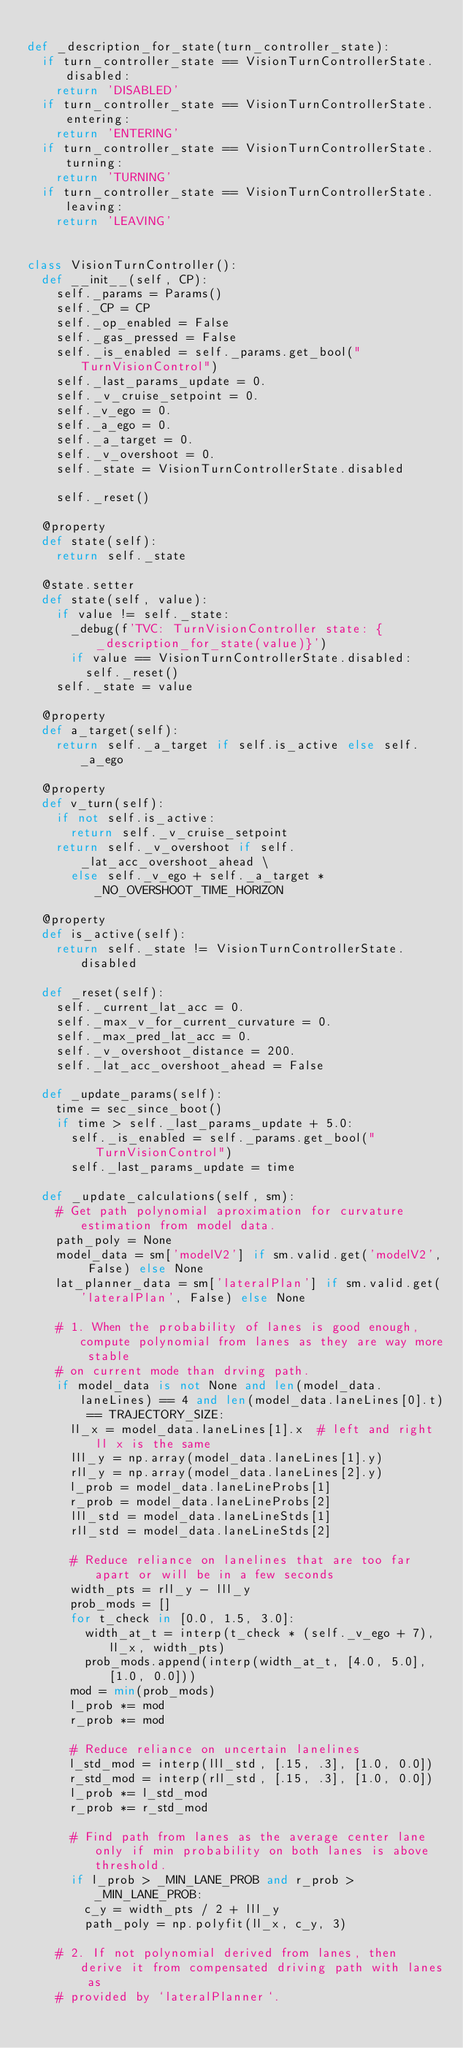<code> <loc_0><loc_0><loc_500><loc_500><_Python_>
def _description_for_state(turn_controller_state):
  if turn_controller_state == VisionTurnControllerState.disabled:
    return 'DISABLED'
  if turn_controller_state == VisionTurnControllerState.entering:
    return 'ENTERING'
  if turn_controller_state == VisionTurnControllerState.turning:
    return 'TURNING'
  if turn_controller_state == VisionTurnControllerState.leaving:
    return 'LEAVING'


class VisionTurnController():
  def __init__(self, CP):
    self._params = Params()
    self._CP = CP
    self._op_enabled = False
    self._gas_pressed = False
    self._is_enabled = self._params.get_bool("TurnVisionControl")
    self._last_params_update = 0.
    self._v_cruise_setpoint = 0.
    self._v_ego = 0.
    self._a_ego = 0.
    self._a_target = 0.
    self._v_overshoot = 0.
    self._state = VisionTurnControllerState.disabled

    self._reset()

  @property
  def state(self):
    return self._state

  @state.setter
  def state(self, value):
    if value != self._state:
      _debug(f'TVC: TurnVisionController state: {_description_for_state(value)}')
      if value == VisionTurnControllerState.disabled:
        self._reset()
    self._state = value

  @property
  def a_target(self):
    return self._a_target if self.is_active else self._a_ego

  @property
  def v_turn(self):
    if not self.is_active:
      return self._v_cruise_setpoint
    return self._v_overshoot if self._lat_acc_overshoot_ahead \
      else self._v_ego + self._a_target * _NO_OVERSHOOT_TIME_HORIZON

  @property
  def is_active(self):
    return self._state != VisionTurnControllerState.disabled

  def _reset(self):
    self._current_lat_acc = 0.
    self._max_v_for_current_curvature = 0.
    self._max_pred_lat_acc = 0.
    self._v_overshoot_distance = 200.
    self._lat_acc_overshoot_ahead = False

  def _update_params(self):
    time = sec_since_boot()
    if time > self._last_params_update + 5.0:
      self._is_enabled = self._params.get_bool("TurnVisionControl")
      self._last_params_update = time

  def _update_calculations(self, sm):
    # Get path polynomial aproximation for curvature estimation from model data.
    path_poly = None
    model_data = sm['modelV2'] if sm.valid.get('modelV2', False) else None
    lat_planner_data = sm['lateralPlan'] if sm.valid.get('lateralPlan', False) else None

    # 1. When the probability of lanes is good enough, compute polynomial from lanes as they are way more stable
    # on current mode than drving path.
    if model_data is not None and len(model_data.laneLines) == 4 and len(model_data.laneLines[0].t) == TRAJECTORY_SIZE:
      ll_x = model_data.laneLines[1].x  # left and right ll x is the same
      lll_y = np.array(model_data.laneLines[1].y)
      rll_y = np.array(model_data.laneLines[2].y)
      l_prob = model_data.laneLineProbs[1]
      r_prob = model_data.laneLineProbs[2]
      lll_std = model_data.laneLineStds[1]
      rll_std = model_data.laneLineStds[2]

      # Reduce reliance on lanelines that are too far apart or will be in a few seconds
      width_pts = rll_y - lll_y
      prob_mods = []
      for t_check in [0.0, 1.5, 3.0]:
        width_at_t = interp(t_check * (self._v_ego + 7), ll_x, width_pts)
        prob_mods.append(interp(width_at_t, [4.0, 5.0], [1.0, 0.0]))
      mod = min(prob_mods)
      l_prob *= mod
      r_prob *= mod

      # Reduce reliance on uncertain lanelines
      l_std_mod = interp(lll_std, [.15, .3], [1.0, 0.0])
      r_std_mod = interp(rll_std, [.15, .3], [1.0, 0.0])
      l_prob *= l_std_mod
      r_prob *= r_std_mod

      # Find path from lanes as the average center lane only if min probability on both lanes is above threshold.
      if l_prob > _MIN_LANE_PROB and r_prob > _MIN_LANE_PROB:
        c_y = width_pts / 2 + lll_y
        path_poly = np.polyfit(ll_x, c_y, 3)

    # 2. If not polynomial derived from lanes, then derive it from compensated driving path with lanes as
    # provided by `lateralPlanner`.</code> 